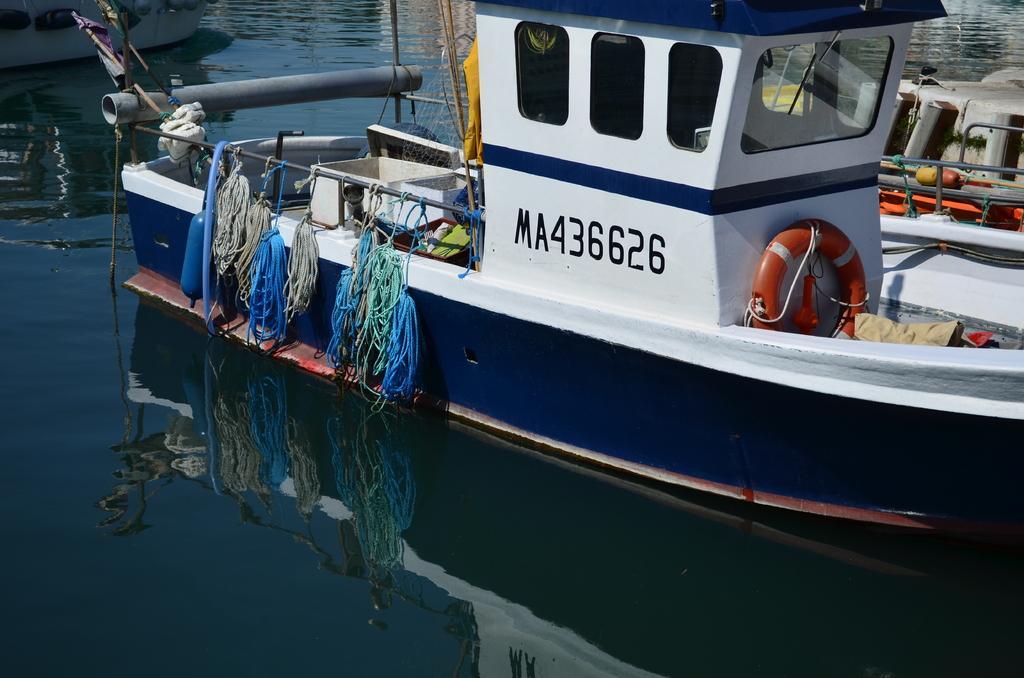Please provide a concise description of this image. In this picture we can see a few boats in the water. There are a few ropes, poles, mesh and other objects are visible in the water. We can see the reflections of the boats in the water. 